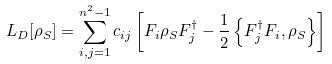<formula> <loc_0><loc_0><loc_500><loc_500>L _ { D } [ \rho _ { S } ] = \sum _ { i , j = 1 } ^ { n ^ { 2 } - 1 } c _ { i j } \left [ F _ { i } \rho _ { S } F _ { j } ^ { \dagger } - \frac { 1 } { 2 } \left \{ F _ { j } ^ { \dagger } F _ { i } , \rho _ { S } \right \} \right ]</formula> 